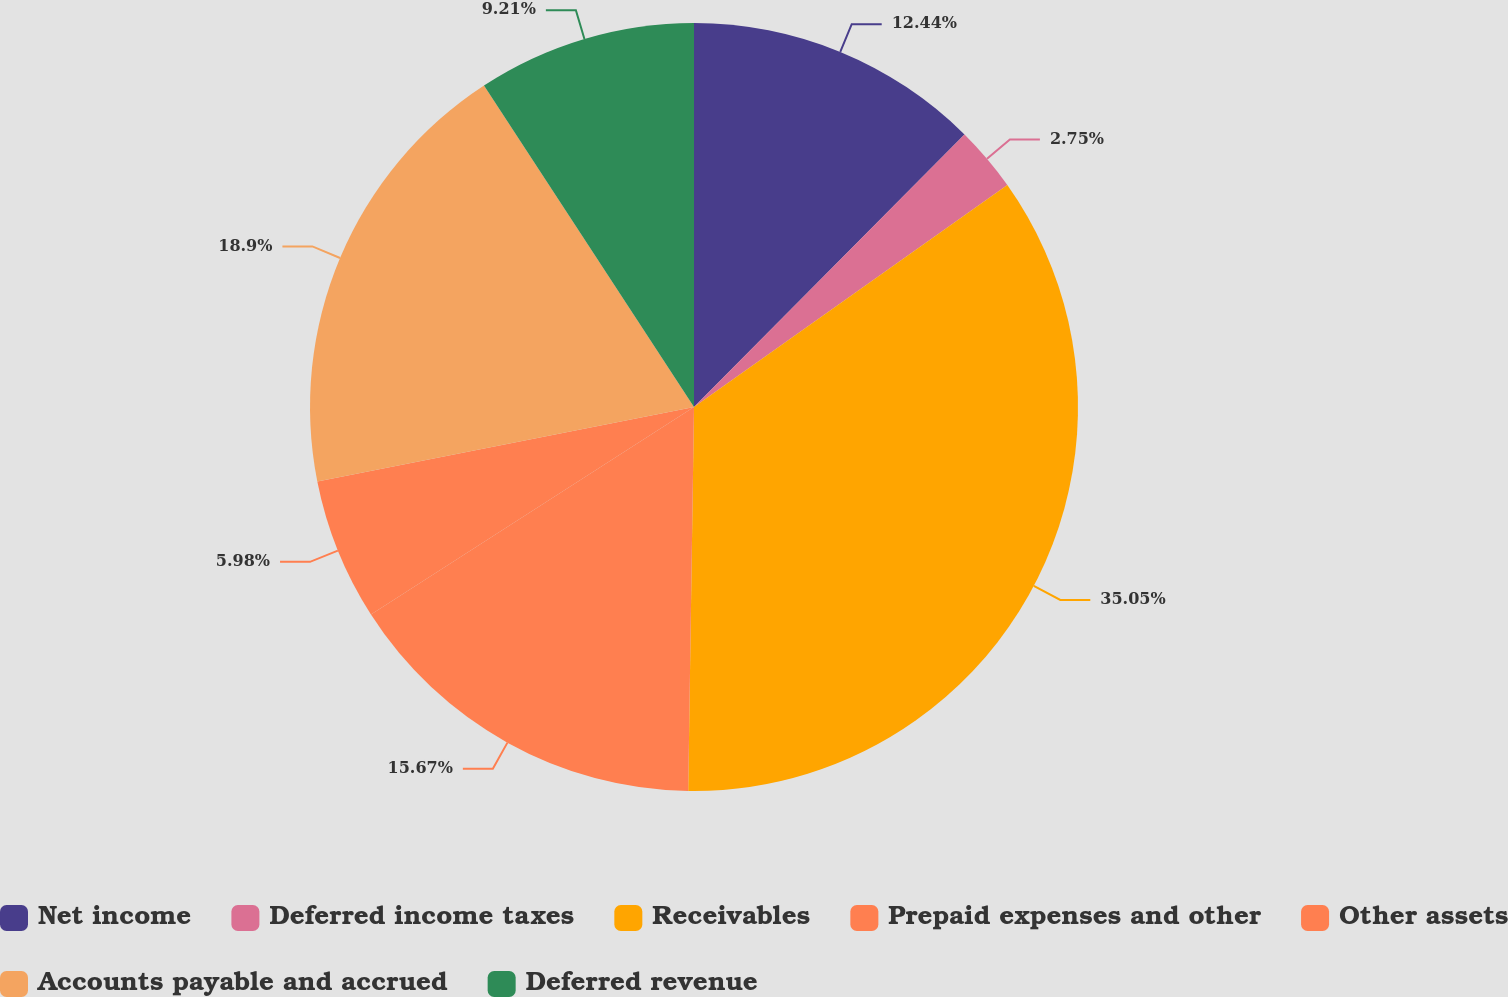Convert chart to OTSL. <chart><loc_0><loc_0><loc_500><loc_500><pie_chart><fcel>Net income<fcel>Deferred income taxes<fcel>Receivables<fcel>Prepaid expenses and other<fcel>Other assets<fcel>Accounts payable and accrued<fcel>Deferred revenue<nl><fcel>12.44%<fcel>2.75%<fcel>35.05%<fcel>15.67%<fcel>5.98%<fcel>18.9%<fcel>9.21%<nl></chart> 